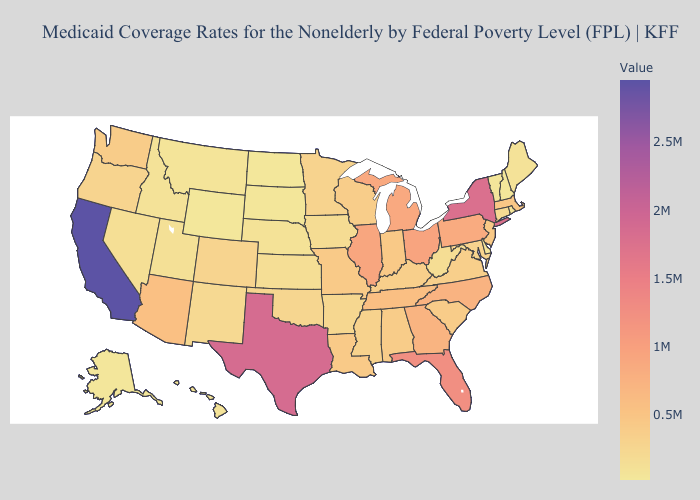Does Ohio have the highest value in the USA?
Give a very brief answer. No. Does the map have missing data?
Answer briefly. No. Does Florida have a higher value than California?
Quick response, please. No. Does Wyoming have the lowest value in the USA?
Concise answer only. Yes. Does the map have missing data?
Keep it brief. No. Among the states that border New Hampshire , does Maine have the lowest value?
Short answer required. No. Does Nebraska have the highest value in the MidWest?
Give a very brief answer. No. 